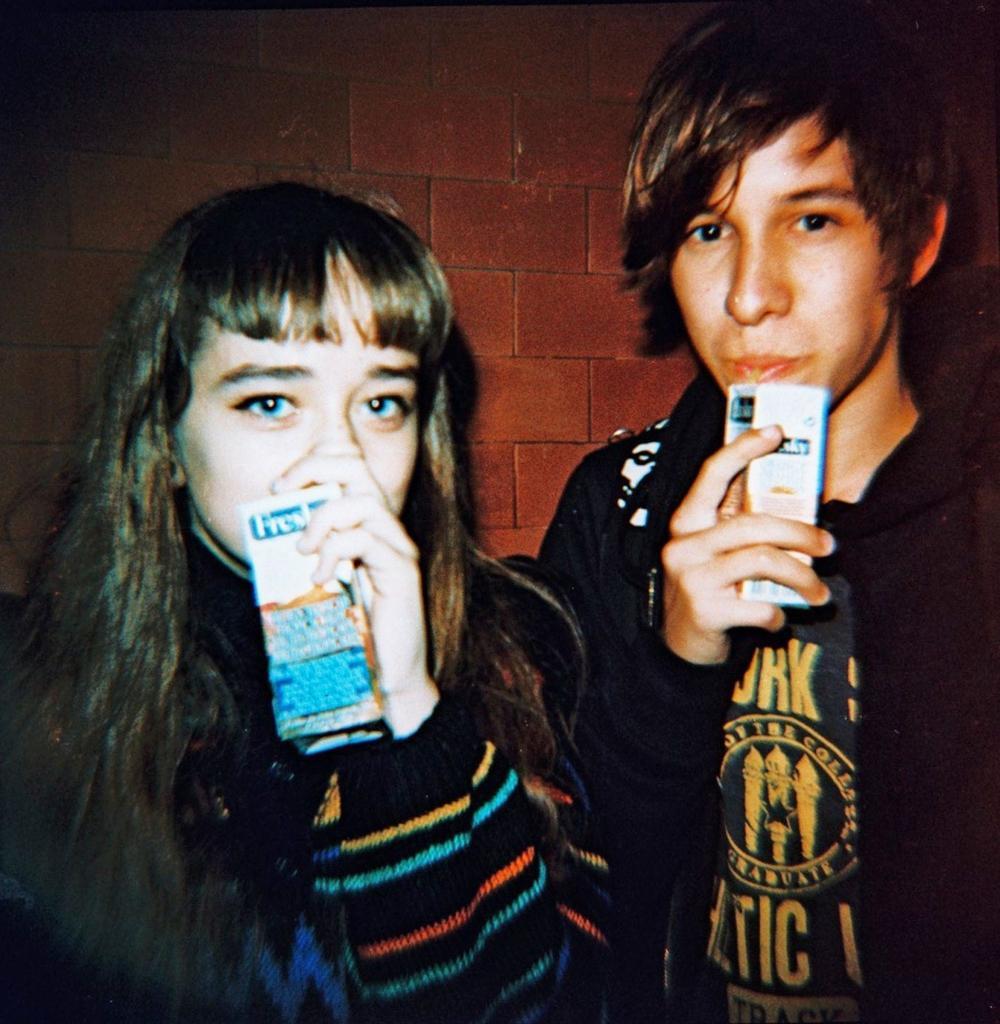In one or two sentences, can you explain what this image depicts? In this picture two person are standing and holding juice. This man is drinking a juice. The wall is built with bricks, it is red in color. Woman wore a jacket of yellow and blue strips. Man wore black jacket. 